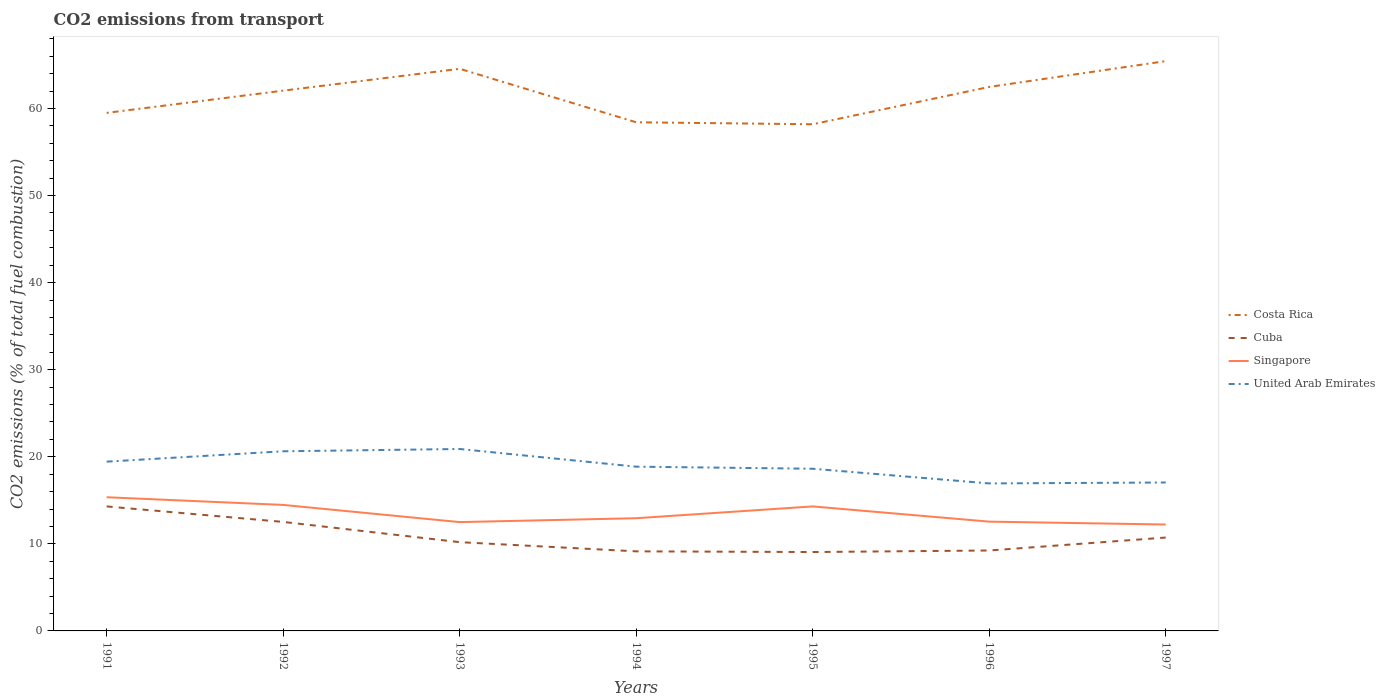Is the number of lines equal to the number of legend labels?
Make the answer very short. Yes. Across all years, what is the maximum total CO2 emitted in Costa Rica?
Give a very brief answer. 58.18. In which year was the total CO2 emitted in Costa Rica maximum?
Give a very brief answer. 1995. What is the total total CO2 emitted in Costa Rica in the graph?
Ensure brevity in your answer.  -2.55. What is the difference between the highest and the second highest total CO2 emitted in Singapore?
Offer a very short reply. 3.13. What is the difference between the highest and the lowest total CO2 emitted in Costa Rica?
Keep it short and to the point. 4. How many lines are there?
Your answer should be very brief. 4. What is the difference between two consecutive major ticks on the Y-axis?
Your answer should be compact. 10. Does the graph contain grids?
Give a very brief answer. No. How many legend labels are there?
Provide a short and direct response. 4. How are the legend labels stacked?
Your answer should be compact. Vertical. What is the title of the graph?
Offer a very short reply. CO2 emissions from transport. What is the label or title of the X-axis?
Ensure brevity in your answer.  Years. What is the label or title of the Y-axis?
Provide a short and direct response. CO2 emissions (% of total fuel combustion). What is the CO2 emissions (% of total fuel combustion) of Costa Rica in 1991?
Make the answer very short. 59.49. What is the CO2 emissions (% of total fuel combustion) in Cuba in 1991?
Keep it short and to the point. 14.3. What is the CO2 emissions (% of total fuel combustion) in Singapore in 1991?
Your answer should be compact. 15.35. What is the CO2 emissions (% of total fuel combustion) in United Arab Emirates in 1991?
Provide a short and direct response. 19.44. What is the CO2 emissions (% of total fuel combustion) in Costa Rica in 1992?
Your answer should be very brief. 62.04. What is the CO2 emissions (% of total fuel combustion) in Cuba in 1992?
Provide a short and direct response. 12.52. What is the CO2 emissions (% of total fuel combustion) in Singapore in 1992?
Keep it short and to the point. 14.47. What is the CO2 emissions (% of total fuel combustion) of United Arab Emirates in 1992?
Your answer should be very brief. 20.63. What is the CO2 emissions (% of total fuel combustion) of Costa Rica in 1993?
Offer a terse response. 64.55. What is the CO2 emissions (% of total fuel combustion) in Cuba in 1993?
Your answer should be compact. 10.19. What is the CO2 emissions (% of total fuel combustion) of Singapore in 1993?
Keep it short and to the point. 12.5. What is the CO2 emissions (% of total fuel combustion) of United Arab Emirates in 1993?
Your answer should be compact. 20.89. What is the CO2 emissions (% of total fuel combustion) of Costa Rica in 1994?
Make the answer very short. 58.41. What is the CO2 emissions (% of total fuel combustion) of Cuba in 1994?
Your response must be concise. 9.14. What is the CO2 emissions (% of total fuel combustion) in Singapore in 1994?
Offer a very short reply. 12.94. What is the CO2 emissions (% of total fuel combustion) in United Arab Emirates in 1994?
Offer a terse response. 18.86. What is the CO2 emissions (% of total fuel combustion) in Costa Rica in 1995?
Give a very brief answer. 58.18. What is the CO2 emissions (% of total fuel combustion) in Cuba in 1995?
Keep it short and to the point. 9.06. What is the CO2 emissions (% of total fuel combustion) in Singapore in 1995?
Provide a short and direct response. 14.3. What is the CO2 emissions (% of total fuel combustion) in United Arab Emirates in 1995?
Make the answer very short. 18.62. What is the CO2 emissions (% of total fuel combustion) in Costa Rica in 1996?
Provide a short and direct response. 62.47. What is the CO2 emissions (% of total fuel combustion) of Cuba in 1996?
Provide a succinct answer. 9.24. What is the CO2 emissions (% of total fuel combustion) of Singapore in 1996?
Provide a short and direct response. 12.55. What is the CO2 emissions (% of total fuel combustion) in United Arab Emirates in 1996?
Provide a succinct answer. 16.94. What is the CO2 emissions (% of total fuel combustion) of Costa Rica in 1997?
Give a very brief answer. 65.43. What is the CO2 emissions (% of total fuel combustion) in Cuba in 1997?
Give a very brief answer. 10.72. What is the CO2 emissions (% of total fuel combustion) of Singapore in 1997?
Keep it short and to the point. 12.22. What is the CO2 emissions (% of total fuel combustion) of United Arab Emirates in 1997?
Offer a terse response. 17.04. Across all years, what is the maximum CO2 emissions (% of total fuel combustion) in Costa Rica?
Provide a succinct answer. 65.43. Across all years, what is the maximum CO2 emissions (% of total fuel combustion) in Cuba?
Your answer should be very brief. 14.3. Across all years, what is the maximum CO2 emissions (% of total fuel combustion) in Singapore?
Make the answer very short. 15.35. Across all years, what is the maximum CO2 emissions (% of total fuel combustion) of United Arab Emirates?
Your answer should be very brief. 20.89. Across all years, what is the minimum CO2 emissions (% of total fuel combustion) in Costa Rica?
Your response must be concise. 58.18. Across all years, what is the minimum CO2 emissions (% of total fuel combustion) of Cuba?
Your response must be concise. 9.06. Across all years, what is the minimum CO2 emissions (% of total fuel combustion) in Singapore?
Provide a succinct answer. 12.22. Across all years, what is the minimum CO2 emissions (% of total fuel combustion) of United Arab Emirates?
Offer a very short reply. 16.94. What is the total CO2 emissions (% of total fuel combustion) of Costa Rica in the graph?
Provide a succinct answer. 430.57. What is the total CO2 emissions (% of total fuel combustion) of Cuba in the graph?
Make the answer very short. 75.16. What is the total CO2 emissions (% of total fuel combustion) of Singapore in the graph?
Provide a short and direct response. 94.33. What is the total CO2 emissions (% of total fuel combustion) in United Arab Emirates in the graph?
Give a very brief answer. 132.43. What is the difference between the CO2 emissions (% of total fuel combustion) of Costa Rica in 1991 and that in 1992?
Give a very brief answer. -2.55. What is the difference between the CO2 emissions (% of total fuel combustion) in Cuba in 1991 and that in 1992?
Give a very brief answer. 1.78. What is the difference between the CO2 emissions (% of total fuel combustion) of Singapore in 1991 and that in 1992?
Your response must be concise. 0.88. What is the difference between the CO2 emissions (% of total fuel combustion) of United Arab Emirates in 1991 and that in 1992?
Give a very brief answer. -1.19. What is the difference between the CO2 emissions (% of total fuel combustion) of Costa Rica in 1991 and that in 1993?
Your answer should be very brief. -5.06. What is the difference between the CO2 emissions (% of total fuel combustion) in Cuba in 1991 and that in 1993?
Your answer should be very brief. 4.1. What is the difference between the CO2 emissions (% of total fuel combustion) of Singapore in 1991 and that in 1993?
Make the answer very short. 2.85. What is the difference between the CO2 emissions (% of total fuel combustion) of United Arab Emirates in 1991 and that in 1993?
Your response must be concise. -1.45. What is the difference between the CO2 emissions (% of total fuel combustion) in Cuba in 1991 and that in 1994?
Give a very brief answer. 5.16. What is the difference between the CO2 emissions (% of total fuel combustion) of Singapore in 1991 and that in 1994?
Ensure brevity in your answer.  2.41. What is the difference between the CO2 emissions (% of total fuel combustion) in United Arab Emirates in 1991 and that in 1994?
Your answer should be very brief. 0.58. What is the difference between the CO2 emissions (% of total fuel combustion) in Costa Rica in 1991 and that in 1995?
Keep it short and to the point. 1.31. What is the difference between the CO2 emissions (% of total fuel combustion) in Cuba in 1991 and that in 1995?
Provide a succinct answer. 5.24. What is the difference between the CO2 emissions (% of total fuel combustion) of Singapore in 1991 and that in 1995?
Your response must be concise. 1.05. What is the difference between the CO2 emissions (% of total fuel combustion) in United Arab Emirates in 1991 and that in 1995?
Your answer should be compact. 0.81. What is the difference between the CO2 emissions (% of total fuel combustion) in Costa Rica in 1991 and that in 1996?
Provide a short and direct response. -2.98. What is the difference between the CO2 emissions (% of total fuel combustion) of Cuba in 1991 and that in 1996?
Provide a succinct answer. 5.06. What is the difference between the CO2 emissions (% of total fuel combustion) in Singapore in 1991 and that in 1996?
Keep it short and to the point. 2.8. What is the difference between the CO2 emissions (% of total fuel combustion) of United Arab Emirates in 1991 and that in 1996?
Your answer should be compact. 2.5. What is the difference between the CO2 emissions (% of total fuel combustion) in Costa Rica in 1991 and that in 1997?
Your answer should be very brief. -5.94. What is the difference between the CO2 emissions (% of total fuel combustion) in Cuba in 1991 and that in 1997?
Offer a terse response. 3.57. What is the difference between the CO2 emissions (% of total fuel combustion) in Singapore in 1991 and that in 1997?
Offer a very short reply. 3.13. What is the difference between the CO2 emissions (% of total fuel combustion) of United Arab Emirates in 1991 and that in 1997?
Offer a terse response. 2.39. What is the difference between the CO2 emissions (% of total fuel combustion) in Costa Rica in 1992 and that in 1993?
Offer a terse response. -2.51. What is the difference between the CO2 emissions (% of total fuel combustion) in Cuba in 1992 and that in 1993?
Give a very brief answer. 2.32. What is the difference between the CO2 emissions (% of total fuel combustion) in Singapore in 1992 and that in 1993?
Your answer should be compact. 1.97. What is the difference between the CO2 emissions (% of total fuel combustion) of United Arab Emirates in 1992 and that in 1993?
Provide a succinct answer. -0.26. What is the difference between the CO2 emissions (% of total fuel combustion) in Costa Rica in 1992 and that in 1994?
Provide a short and direct response. 3.63. What is the difference between the CO2 emissions (% of total fuel combustion) in Cuba in 1992 and that in 1994?
Offer a terse response. 3.38. What is the difference between the CO2 emissions (% of total fuel combustion) in Singapore in 1992 and that in 1994?
Your response must be concise. 1.53. What is the difference between the CO2 emissions (% of total fuel combustion) in United Arab Emirates in 1992 and that in 1994?
Give a very brief answer. 1.77. What is the difference between the CO2 emissions (% of total fuel combustion) of Costa Rica in 1992 and that in 1995?
Offer a terse response. 3.86. What is the difference between the CO2 emissions (% of total fuel combustion) of Cuba in 1992 and that in 1995?
Make the answer very short. 3.46. What is the difference between the CO2 emissions (% of total fuel combustion) in Singapore in 1992 and that in 1995?
Your answer should be very brief. 0.17. What is the difference between the CO2 emissions (% of total fuel combustion) in United Arab Emirates in 1992 and that in 1995?
Your response must be concise. 2. What is the difference between the CO2 emissions (% of total fuel combustion) in Costa Rica in 1992 and that in 1996?
Your answer should be very brief. -0.43. What is the difference between the CO2 emissions (% of total fuel combustion) in Cuba in 1992 and that in 1996?
Your response must be concise. 3.28. What is the difference between the CO2 emissions (% of total fuel combustion) in Singapore in 1992 and that in 1996?
Give a very brief answer. 1.92. What is the difference between the CO2 emissions (% of total fuel combustion) in United Arab Emirates in 1992 and that in 1996?
Ensure brevity in your answer.  3.69. What is the difference between the CO2 emissions (% of total fuel combustion) in Costa Rica in 1992 and that in 1997?
Your response must be concise. -3.39. What is the difference between the CO2 emissions (% of total fuel combustion) in Cuba in 1992 and that in 1997?
Ensure brevity in your answer.  1.79. What is the difference between the CO2 emissions (% of total fuel combustion) of Singapore in 1992 and that in 1997?
Your answer should be very brief. 2.25. What is the difference between the CO2 emissions (% of total fuel combustion) in United Arab Emirates in 1992 and that in 1997?
Keep it short and to the point. 3.58. What is the difference between the CO2 emissions (% of total fuel combustion) in Costa Rica in 1993 and that in 1994?
Give a very brief answer. 6.14. What is the difference between the CO2 emissions (% of total fuel combustion) in Cuba in 1993 and that in 1994?
Ensure brevity in your answer.  1.06. What is the difference between the CO2 emissions (% of total fuel combustion) in Singapore in 1993 and that in 1994?
Offer a very short reply. -0.45. What is the difference between the CO2 emissions (% of total fuel combustion) in United Arab Emirates in 1993 and that in 1994?
Your response must be concise. 2.03. What is the difference between the CO2 emissions (% of total fuel combustion) of Costa Rica in 1993 and that in 1995?
Make the answer very short. 6.37. What is the difference between the CO2 emissions (% of total fuel combustion) in Cuba in 1993 and that in 1995?
Ensure brevity in your answer.  1.14. What is the difference between the CO2 emissions (% of total fuel combustion) of Singapore in 1993 and that in 1995?
Your answer should be very brief. -1.8. What is the difference between the CO2 emissions (% of total fuel combustion) in United Arab Emirates in 1993 and that in 1995?
Offer a very short reply. 2.27. What is the difference between the CO2 emissions (% of total fuel combustion) in Costa Rica in 1993 and that in 1996?
Ensure brevity in your answer.  2.08. What is the difference between the CO2 emissions (% of total fuel combustion) in Cuba in 1993 and that in 1996?
Offer a terse response. 0.96. What is the difference between the CO2 emissions (% of total fuel combustion) of Singapore in 1993 and that in 1996?
Your response must be concise. -0.05. What is the difference between the CO2 emissions (% of total fuel combustion) in United Arab Emirates in 1993 and that in 1996?
Make the answer very short. 3.95. What is the difference between the CO2 emissions (% of total fuel combustion) of Costa Rica in 1993 and that in 1997?
Your response must be concise. -0.88. What is the difference between the CO2 emissions (% of total fuel combustion) in Cuba in 1993 and that in 1997?
Keep it short and to the point. -0.53. What is the difference between the CO2 emissions (% of total fuel combustion) in Singapore in 1993 and that in 1997?
Keep it short and to the point. 0.28. What is the difference between the CO2 emissions (% of total fuel combustion) in United Arab Emirates in 1993 and that in 1997?
Keep it short and to the point. 3.85. What is the difference between the CO2 emissions (% of total fuel combustion) of Costa Rica in 1994 and that in 1995?
Provide a short and direct response. 0.23. What is the difference between the CO2 emissions (% of total fuel combustion) in Cuba in 1994 and that in 1995?
Keep it short and to the point. 0.08. What is the difference between the CO2 emissions (% of total fuel combustion) of Singapore in 1994 and that in 1995?
Offer a very short reply. -1.35. What is the difference between the CO2 emissions (% of total fuel combustion) of United Arab Emirates in 1994 and that in 1995?
Provide a short and direct response. 0.24. What is the difference between the CO2 emissions (% of total fuel combustion) of Costa Rica in 1994 and that in 1996?
Keep it short and to the point. -4.06. What is the difference between the CO2 emissions (% of total fuel combustion) in Cuba in 1994 and that in 1996?
Offer a terse response. -0.1. What is the difference between the CO2 emissions (% of total fuel combustion) in Singapore in 1994 and that in 1996?
Make the answer very short. 0.39. What is the difference between the CO2 emissions (% of total fuel combustion) in United Arab Emirates in 1994 and that in 1996?
Make the answer very short. 1.92. What is the difference between the CO2 emissions (% of total fuel combustion) of Costa Rica in 1994 and that in 1997?
Offer a very short reply. -7.02. What is the difference between the CO2 emissions (% of total fuel combustion) in Cuba in 1994 and that in 1997?
Make the answer very short. -1.59. What is the difference between the CO2 emissions (% of total fuel combustion) in Singapore in 1994 and that in 1997?
Your response must be concise. 0.72. What is the difference between the CO2 emissions (% of total fuel combustion) of United Arab Emirates in 1994 and that in 1997?
Ensure brevity in your answer.  1.82. What is the difference between the CO2 emissions (% of total fuel combustion) in Costa Rica in 1995 and that in 1996?
Ensure brevity in your answer.  -4.29. What is the difference between the CO2 emissions (% of total fuel combustion) of Cuba in 1995 and that in 1996?
Provide a short and direct response. -0.18. What is the difference between the CO2 emissions (% of total fuel combustion) of Singapore in 1995 and that in 1996?
Provide a succinct answer. 1.75. What is the difference between the CO2 emissions (% of total fuel combustion) of United Arab Emirates in 1995 and that in 1996?
Provide a succinct answer. 1.69. What is the difference between the CO2 emissions (% of total fuel combustion) of Costa Rica in 1995 and that in 1997?
Ensure brevity in your answer.  -7.25. What is the difference between the CO2 emissions (% of total fuel combustion) of Cuba in 1995 and that in 1997?
Give a very brief answer. -1.67. What is the difference between the CO2 emissions (% of total fuel combustion) in Singapore in 1995 and that in 1997?
Provide a short and direct response. 2.08. What is the difference between the CO2 emissions (% of total fuel combustion) in United Arab Emirates in 1995 and that in 1997?
Offer a very short reply. 1.58. What is the difference between the CO2 emissions (% of total fuel combustion) in Costa Rica in 1996 and that in 1997?
Make the answer very short. -2.96. What is the difference between the CO2 emissions (% of total fuel combustion) of Cuba in 1996 and that in 1997?
Give a very brief answer. -1.49. What is the difference between the CO2 emissions (% of total fuel combustion) in Singapore in 1996 and that in 1997?
Ensure brevity in your answer.  0.33. What is the difference between the CO2 emissions (% of total fuel combustion) of United Arab Emirates in 1996 and that in 1997?
Your answer should be very brief. -0.11. What is the difference between the CO2 emissions (% of total fuel combustion) in Costa Rica in 1991 and the CO2 emissions (% of total fuel combustion) in Cuba in 1992?
Your response must be concise. 46.97. What is the difference between the CO2 emissions (% of total fuel combustion) of Costa Rica in 1991 and the CO2 emissions (% of total fuel combustion) of Singapore in 1992?
Your answer should be very brief. 45.02. What is the difference between the CO2 emissions (% of total fuel combustion) of Costa Rica in 1991 and the CO2 emissions (% of total fuel combustion) of United Arab Emirates in 1992?
Your response must be concise. 38.86. What is the difference between the CO2 emissions (% of total fuel combustion) of Cuba in 1991 and the CO2 emissions (% of total fuel combustion) of Singapore in 1992?
Your response must be concise. -0.17. What is the difference between the CO2 emissions (% of total fuel combustion) in Cuba in 1991 and the CO2 emissions (% of total fuel combustion) in United Arab Emirates in 1992?
Offer a terse response. -6.33. What is the difference between the CO2 emissions (% of total fuel combustion) of Singapore in 1991 and the CO2 emissions (% of total fuel combustion) of United Arab Emirates in 1992?
Ensure brevity in your answer.  -5.28. What is the difference between the CO2 emissions (% of total fuel combustion) in Costa Rica in 1991 and the CO2 emissions (% of total fuel combustion) in Cuba in 1993?
Your answer should be very brief. 49.3. What is the difference between the CO2 emissions (% of total fuel combustion) in Costa Rica in 1991 and the CO2 emissions (% of total fuel combustion) in Singapore in 1993?
Provide a short and direct response. 46.99. What is the difference between the CO2 emissions (% of total fuel combustion) of Costa Rica in 1991 and the CO2 emissions (% of total fuel combustion) of United Arab Emirates in 1993?
Keep it short and to the point. 38.6. What is the difference between the CO2 emissions (% of total fuel combustion) in Cuba in 1991 and the CO2 emissions (% of total fuel combustion) in Singapore in 1993?
Ensure brevity in your answer.  1.8. What is the difference between the CO2 emissions (% of total fuel combustion) of Cuba in 1991 and the CO2 emissions (% of total fuel combustion) of United Arab Emirates in 1993?
Give a very brief answer. -6.59. What is the difference between the CO2 emissions (% of total fuel combustion) in Singapore in 1991 and the CO2 emissions (% of total fuel combustion) in United Arab Emirates in 1993?
Your answer should be compact. -5.54. What is the difference between the CO2 emissions (% of total fuel combustion) in Costa Rica in 1991 and the CO2 emissions (% of total fuel combustion) in Cuba in 1994?
Give a very brief answer. 50.35. What is the difference between the CO2 emissions (% of total fuel combustion) in Costa Rica in 1991 and the CO2 emissions (% of total fuel combustion) in Singapore in 1994?
Make the answer very short. 46.55. What is the difference between the CO2 emissions (% of total fuel combustion) in Costa Rica in 1991 and the CO2 emissions (% of total fuel combustion) in United Arab Emirates in 1994?
Provide a succinct answer. 40.63. What is the difference between the CO2 emissions (% of total fuel combustion) in Cuba in 1991 and the CO2 emissions (% of total fuel combustion) in Singapore in 1994?
Provide a succinct answer. 1.35. What is the difference between the CO2 emissions (% of total fuel combustion) of Cuba in 1991 and the CO2 emissions (% of total fuel combustion) of United Arab Emirates in 1994?
Provide a short and direct response. -4.57. What is the difference between the CO2 emissions (% of total fuel combustion) in Singapore in 1991 and the CO2 emissions (% of total fuel combustion) in United Arab Emirates in 1994?
Your answer should be very brief. -3.51. What is the difference between the CO2 emissions (% of total fuel combustion) in Costa Rica in 1991 and the CO2 emissions (% of total fuel combustion) in Cuba in 1995?
Offer a very short reply. 50.43. What is the difference between the CO2 emissions (% of total fuel combustion) in Costa Rica in 1991 and the CO2 emissions (% of total fuel combustion) in Singapore in 1995?
Provide a short and direct response. 45.19. What is the difference between the CO2 emissions (% of total fuel combustion) in Costa Rica in 1991 and the CO2 emissions (% of total fuel combustion) in United Arab Emirates in 1995?
Make the answer very short. 40.86. What is the difference between the CO2 emissions (% of total fuel combustion) of Cuba in 1991 and the CO2 emissions (% of total fuel combustion) of Singapore in 1995?
Provide a short and direct response. -0. What is the difference between the CO2 emissions (% of total fuel combustion) of Cuba in 1991 and the CO2 emissions (% of total fuel combustion) of United Arab Emirates in 1995?
Your answer should be compact. -4.33. What is the difference between the CO2 emissions (% of total fuel combustion) in Singapore in 1991 and the CO2 emissions (% of total fuel combustion) in United Arab Emirates in 1995?
Provide a succinct answer. -3.27. What is the difference between the CO2 emissions (% of total fuel combustion) in Costa Rica in 1991 and the CO2 emissions (% of total fuel combustion) in Cuba in 1996?
Your answer should be very brief. 50.25. What is the difference between the CO2 emissions (% of total fuel combustion) of Costa Rica in 1991 and the CO2 emissions (% of total fuel combustion) of Singapore in 1996?
Your response must be concise. 46.94. What is the difference between the CO2 emissions (% of total fuel combustion) of Costa Rica in 1991 and the CO2 emissions (% of total fuel combustion) of United Arab Emirates in 1996?
Provide a succinct answer. 42.55. What is the difference between the CO2 emissions (% of total fuel combustion) of Cuba in 1991 and the CO2 emissions (% of total fuel combustion) of Singapore in 1996?
Your answer should be compact. 1.75. What is the difference between the CO2 emissions (% of total fuel combustion) in Cuba in 1991 and the CO2 emissions (% of total fuel combustion) in United Arab Emirates in 1996?
Offer a very short reply. -2.64. What is the difference between the CO2 emissions (% of total fuel combustion) in Singapore in 1991 and the CO2 emissions (% of total fuel combustion) in United Arab Emirates in 1996?
Keep it short and to the point. -1.59. What is the difference between the CO2 emissions (% of total fuel combustion) of Costa Rica in 1991 and the CO2 emissions (% of total fuel combustion) of Cuba in 1997?
Give a very brief answer. 48.77. What is the difference between the CO2 emissions (% of total fuel combustion) in Costa Rica in 1991 and the CO2 emissions (% of total fuel combustion) in Singapore in 1997?
Your answer should be very brief. 47.27. What is the difference between the CO2 emissions (% of total fuel combustion) of Costa Rica in 1991 and the CO2 emissions (% of total fuel combustion) of United Arab Emirates in 1997?
Your response must be concise. 42.44. What is the difference between the CO2 emissions (% of total fuel combustion) in Cuba in 1991 and the CO2 emissions (% of total fuel combustion) in Singapore in 1997?
Give a very brief answer. 2.08. What is the difference between the CO2 emissions (% of total fuel combustion) in Cuba in 1991 and the CO2 emissions (% of total fuel combustion) in United Arab Emirates in 1997?
Keep it short and to the point. -2.75. What is the difference between the CO2 emissions (% of total fuel combustion) of Singapore in 1991 and the CO2 emissions (% of total fuel combustion) of United Arab Emirates in 1997?
Provide a short and direct response. -1.69. What is the difference between the CO2 emissions (% of total fuel combustion) in Costa Rica in 1992 and the CO2 emissions (% of total fuel combustion) in Cuba in 1993?
Ensure brevity in your answer.  51.85. What is the difference between the CO2 emissions (% of total fuel combustion) of Costa Rica in 1992 and the CO2 emissions (% of total fuel combustion) of Singapore in 1993?
Your response must be concise. 49.55. What is the difference between the CO2 emissions (% of total fuel combustion) in Costa Rica in 1992 and the CO2 emissions (% of total fuel combustion) in United Arab Emirates in 1993?
Your answer should be very brief. 41.15. What is the difference between the CO2 emissions (% of total fuel combustion) of Cuba in 1992 and the CO2 emissions (% of total fuel combustion) of Singapore in 1993?
Offer a very short reply. 0.02. What is the difference between the CO2 emissions (% of total fuel combustion) of Cuba in 1992 and the CO2 emissions (% of total fuel combustion) of United Arab Emirates in 1993?
Offer a very short reply. -8.37. What is the difference between the CO2 emissions (% of total fuel combustion) of Singapore in 1992 and the CO2 emissions (% of total fuel combustion) of United Arab Emirates in 1993?
Your answer should be compact. -6.42. What is the difference between the CO2 emissions (% of total fuel combustion) in Costa Rica in 1992 and the CO2 emissions (% of total fuel combustion) in Cuba in 1994?
Your response must be concise. 52.9. What is the difference between the CO2 emissions (% of total fuel combustion) of Costa Rica in 1992 and the CO2 emissions (% of total fuel combustion) of Singapore in 1994?
Provide a short and direct response. 49.1. What is the difference between the CO2 emissions (% of total fuel combustion) in Costa Rica in 1992 and the CO2 emissions (% of total fuel combustion) in United Arab Emirates in 1994?
Your response must be concise. 43.18. What is the difference between the CO2 emissions (% of total fuel combustion) in Cuba in 1992 and the CO2 emissions (% of total fuel combustion) in Singapore in 1994?
Your answer should be very brief. -0.42. What is the difference between the CO2 emissions (% of total fuel combustion) in Cuba in 1992 and the CO2 emissions (% of total fuel combustion) in United Arab Emirates in 1994?
Provide a succinct answer. -6.34. What is the difference between the CO2 emissions (% of total fuel combustion) of Singapore in 1992 and the CO2 emissions (% of total fuel combustion) of United Arab Emirates in 1994?
Your response must be concise. -4.39. What is the difference between the CO2 emissions (% of total fuel combustion) of Costa Rica in 1992 and the CO2 emissions (% of total fuel combustion) of Cuba in 1995?
Your response must be concise. 52.98. What is the difference between the CO2 emissions (% of total fuel combustion) in Costa Rica in 1992 and the CO2 emissions (% of total fuel combustion) in Singapore in 1995?
Ensure brevity in your answer.  47.75. What is the difference between the CO2 emissions (% of total fuel combustion) in Costa Rica in 1992 and the CO2 emissions (% of total fuel combustion) in United Arab Emirates in 1995?
Your answer should be compact. 43.42. What is the difference between the CO2 emissions (% of total fuel combustion) of Cuba in 1992 and the CO2 emissions (% of total fuel combustion) of Singapore in 1995?
Keep it short and to the point. -1.78. What is the difference between the CO2 emissions (% of total fuel combustion) of Cuba in 1992 and the CO2 emissions (% of total fuel combustion) of United Arab Emirates in 1995?
Ensure brevity in your answer.  -6.11. What is the difference between the CO2 emissions (% of total fuel combustion) of Singapore in 1992 and the CO2 emissions (% of total fuel combustion) of United Arab Emirates in 1995?
Your answer should be compact. -4.15. What is the difference between the CO2 emissions (% of total fuel combustion) of Costa Rica in 1992 and the CO2 emissions (% of total fuel combustion) of Cuba in 1996?
Your response must be concise. 52.81. What is the difference between the CO2 emissions (% of total fuel combustion) in Costa Rica in 1992 and the CO2 emissions (% of total fuel combustion) in Singapore in 1996?
Make the answer very short. 49.49. What is the difference between the CO2 emissions (% of total fuel combustion) of Costa Rica in 1992 and the CO2 emissions (% of total fuel combustion) of United Arab Emirates in 1996?
Provide a short and direct response. 45.1. What is the difference between the CO2 emissions (% of total fuel combustion) in Cuba in 1992 and the CO2 emissions (% of total fuel combustion) in Singapore in 1996?
Your response must be concise. -0.03. What is the difference between the CO2 emissions (% of total fuel combustion) in Cuba in 1992 and the CO2 emissions (% of total fuel combustion) in United Arab Emirates in 1996?
Offer a terse response. -4.42. What is the difference between the CO2 emissions (% of total fuel combustion) in Singapore in 1992 and the CO2 emissions (% of total fuel combustion) in United Arab Emirates in 1996?
Ensure brevity in your answer.  -2.47. What is the difference between the CO2 emissions (% of total fuel combustion) in Costa Rica in 1992 and the CO2 emissions (% of total fuel combustion) in Cuba in 1997?
Keep it short and to the point. 51.32. What is the difference between the CO2 emissions (% of total fuel combustion) of Costa Rica in 1992 and the CO2 emissions (% of total fuel combustion) of Singapore in 1997?
Keep it short and to the point. 49.82. What is the difference between the CO2 emissions (% of total fuel combustion) of Costa Rica in 1992 and the CO2 emissions (% of total fuel combustion) of United Arab Emirates in 1997?
Offer a terse response. 45. What is the difference between the CO2 emissions (% of total fuel combustion) in Cuba in 1992 and the CO2 emissions (% of total fuel combustion) in Singapore in 1997?
Give a very brief answer. 0.3. What is the difference between the CO2 emissions (% of total fuel combustion) in Cuba in 1992 and the CO2 emissions (% of total fuel combustion) in United Arab Emirates in 1997?
Make the answer very short. -4.53. What is the difference between the CO2 emissions (% of total fuel combustion) in Singapore in 1992 and the CO2 emissions (% of total fuel combustion) in United Arab Emirates in 1997?
Your response must be concise. -2.57. What is the difference between the CO2 emissions (% of total fuel combustion) of Costa Rica in 1993 and the CO2 emissions (% of total fuel combustion) of Cuba in 1994?
Make the answer very short. 55.41. What is the difference between the CO2 emissions (% of total fuel combustion) of Costa Rica in 1993 and the CO2 emissions (% of total fuel combustion) of Singapore in 1994?
Offer a terse response. 51.61. What is the difference between the CO2 emissions (% of total fuel combustion) in Costa Rica in 1993 and the CO2 emissions (% of total fuel combustion) in United Arab Emirates in 1994?
Offer a terse response. 45.69. What is the difference between the CO2 emissions (% of total fuel combustion) in Cuba in 1993 and the CO2 emissions (% of total fuel combustion) in Singapore in 1994?
Make the answer very short. -2.75. What is the difference between the CO2 emissions (% of total fuel combustion) in Cuba in 1993 and the CO2 emissions (% of total fuel combustion) in United Arab Emirates in 1994?
Provide a short and direct response. -8.67. What is the difference between the CO2 emissions (% of total fuel combustion) of Singapore in 1993 and the CO2 emissions (% of total fuel combustion) of United Arab Emirates in 1994?
Keep it short and to the point. -6.36. What is the difference between the CO2 emissions (% of total fuel combustion) of Costa Rica in 1993 and the CO2 emissions (% of total fuel combustion) of Cuba in 1995?
Your answer should be very brief. 55.49. What is the difference between the CO2 emissions (% of total fuel combustion) in Costa Rica in 1993 and the CO2 emissions (% of total fuel combustion) in Singapore in 1995?
Ensure brevity in your answer.  50.25. What is the difference between the CO2 emissions (% of total fuel combustion) in Costa Rica in 1993 and the CO2 emissions (% of total fuel combustion) in United Arab Emirates in 1995?
Your answer should be compact. 45.93. What is the difference between the CO2 emissions (% of total fuel combustion) in Cuba in 1993 and the CO2 emissions (% of total fuel combustion) in Singapore in 1995?
Offer a very short reply. -4.1. What is the difference between the CO2 emissions (% of total fuel combustion) of Cuba in 1993 and the CO2 emissions (% of total fuel combustion) of United Arab Emirates in 1995?
Ensure brevity in your answer.  -8.43. What is the difference between the CO2 emissions (% of total fuel combustion) in Singapore in 1993 and the CO2 emissions (% of total fuel combustion) in United Arab Emirates in 1995?
Provide a succinct answer. -6.13. What is the difference between the CO2 emissions (% of total fuel combustion) of Costa Rica in 1993 and the CO2 emissions (% of total fuel combustion) of Cuba in 1996?
Offer a terse response. 55.31. What is the difference between the CO2 emissions (% of total fuel combustion) in Costa Rica in 1993 and the CO2 emissions (% of total fuel combustion) in Singapore in 1996?
Your answer should be very brief. 52. What is the difference between the CO2 emissions (% of total fuel combustion) of Costa Rica in 1993 and the CO2 emissions (% of total fuel combustion) of United Arab Emirates in 1996?
Give a very brief answer. 47.61. What is the difference between the CO2 emissions (% of total fuel combustion) of Cuba in 1993 and the CO2 emissions (% of total fuel combustion) of Singapore in 1996?
Offer a terse response. -2.36. What is the difference between the CO2 emissions (% of total fuel combustion) of Cuba in 1993 and the CO2 emissions (% of total fuel combustion) of United Arab Emirates in 1996?
Provide a succinct answer. -6.74. What is the difference between the CO2 emissions (% of total fuel combustion) in Singapore in 1993 and the CO2 emissions (% of total fuel combustion) in United Arab Emirates in 1996?
Your answer should be very brief. -4.44. What is the difference between the CO2 emissions (% of total fuel combustion) in Costa Rica in 1993 and the CO2 emissions (% of total fuel combustion) in Cuba in 1997?
Your response must be concise. 53.83. What is the difference between the CO2 emissions (% of total fuel combustion) in Costa Rica in 1993 and the CO2 emissions (% of total fuel combustion) in Singapore in 1997?
Offer a very short reply. 52.33. What is the difference between the CO2 emissions (% of total fuel combustion) of Costa Rica in 1993 and the CO2 emissions (% of total fuel combustion) of United Arab Emirates in 1997?
Your response must be concise. 47.51. What is the difference between the CO2 emissions (% of total fuel combustion) of Cuba in 1993 and the CO2 emissions (% of total fuel combustion) of Singapore in 1997?
Offer a very short reply. -2.03. What is the difference between the CO2 emissions (% of total fuel combustion) of Cuba in 1993 and the CO2 emissions (% of total fuel combustion) of United Arab Emirates in 1997?
Offer a very short reply. -6.85. What is the difference between the CO2 emissions (% of total fuel combustion) in Singapore in 1993 and the CO2 emissions (% of total fuel combustion) in United Arab Emirates in 1997?
Your response must be concise. -4.55. What is the difference between the CO2 emissions (% of total fuel combustion) in Costa Rica in 1994 and the CO2 emissions (% of total fuel combustion) in Cuba in 1995?
Offer a terse response. 49.35. What is the difference between the CO2 emissions (% of total fuel combustion) in Costa Rica in 1994 and the CO2 emissions (% of total fuel combustion) in Singapore in 1995?
Provide a succinct answer. 44.11. What is the difference between the CO2 emissions (% of total fuel combustion) of Costa Rica in 1994 and the CO2 emissions (% of total fuel combustion) of United Arab Emirates in 1995?
Your response must be concise. 39.78. What is the difference between the CO2 emissions (% of total fuel combustion) of Cuba in 1994 and the CO2 emissions (% of total fuel combustion) of Singapore in 1995?
Ensure brevity in your answer.  -5.16. What is the difference between the CO2 emissions (% of total fuel combustion) of Cuba in 1994 and the CO2 emissions (% of total fuel combustion) of United Arab Emirates in 1995?
Ensure brevity in your answer.  -9.49. What is the difference between the CO2 emissions (% of total fuel combustion) of Singapore in 1994 and the CO2 emissions (% of total fuel combustion) of United Arab Emirates in 1995?
Your answer should be compact. -5.68. What is the difference between the CO2 emissions (% of total fuel combustion) in Costa Rica in 1994 and the CO2 emissions (% of total fuel combustion) in Cuba in 1996?
Ensure brevity in your answer.  49.17. What is the difference between the CO2 emissions (% of total fuel combustion) of Costa Rica in 1994 and the CO2 emissions (% of total fuel combustion) of Singapore in 1996?
Your answer should be very brief. 45.86. What is the difference between the CO2 emissions (% of total fuel combustion) in Costa Rica in 1994 and the CO2 emissions (% of total fuel combustion) in United Arab Emirates in 1996?
Your answer should be compact. 41.47. What is the difference between the CO2 emissions (% of total fuel combustion) in Cuba in 1994 and the CO2 emissions (% of total fuel combustion) in Singapore in 1996?
Make the answer very short. -3.41. What is the difference between the CO2 emissions (% of total fuel combustion) in Cuba in 1994 and the CO2 emissions (% of total fuel combustion) in United Arab Emirates in 1996?
Your response must be concise. -7.8. What is the difference between the CO2 emissions (% of total fuel combustion) of Singapore in 1994 and the CO2 emissions (% of total fuel combustion) of United Arab Emirates in 1996?
Give a very brief answer. -3.99. What is the difference between the CO2 emissions (% of total fuel combustion) in Costa Rica in 1994 and the CO2 emissions (% of total fuel combustion) in Cuba in 1997?
Give a very brief answer. 47.69. What is the difference between the CO2 emissions (% of total fuel combustion) of Costa Rica in 1994 and the CO2 emissions (% of total fuel combustion) of Singapore in 1997?
Your answer should be compact. 46.19. What is the difference between the CO2 emissions (% of total fuel combustion) of Costa Rica in 1994 and the CO2 emissions (% of total fuel combustion) of United Arab Emirates in 1997?
Offer a terse response. 41.36. What is the difference between the CO2 emissions (% of total fuel combustion) in Cuba in 1994 and the CO2 emissions (% of total fuel combustion) in Singapore in 1997?
Your response must be concise. -3.08. What is the difference between the CO2 emissions (% of total fuel combustion) of Cuba in 1994 and the CO2 emissions (% of total fuel combustion) of United Arab Emirates in 1997?
Provide a succinct answer. -7.91. What is the difference between the CO2 emissions (% of total fuel combustion) of Singapore in 1994 and the CO2 emissions (% of total fuel combustion) of United Arab Emirates in 1997?
Your response must be concise. -4.1. What is the difference between the CO2 emissions (% of total fuel combustion) of Costa Rica in 1995 and the CO2 emissions (% of total fuel combustion) of Cuba in 1996?
Your answer should be compact. 48.95. What is the difference between the CO2 emissions (% of total fuel combustion) in Costa Rica in 1995 and the CO2 emissions (% of total fuel combustion) in Singapore in 1996?
Give a very brief answer. 45.63. What is the difference between the CO2 emissions (% of total fuel combustion) of Costa Rica in 1995 and the CO2 emissions (% of total fuel combustion) of United Arab Emirates in 1996?
Ensure brevity in your answer.  41.24. What is the difference between the CO2 emissions (% of total fuel combustion) in Cuba in 1995 and the CO2 emissions (% of total fuel combustion) in Singapore in 1996?
Ensure brevity in your answer.  -3.49. What is the difference between the CO2 emissions (% of total fuel combustion) in Cuba in 1995 and the CO2 emissions (% of total fuel combustion) in United Arab Emirates in 1996?
Provide a succinct answer. -7.88. What is the difference between the CO2 emissions (% of total fuel combustion) in Singapore in 1995 and the CO2 emissions (% of total fuel combustion) in United Arab Emirates in 1996?
Provide a succinct answer. -2.64. What is the difference between the CO2 emissions (% of total fuel combustion) of Costa Rica in 1995 and the CO2 emissions (% of total fuel combustion) of Cuba in 1997?
Your answer should be compact. 47.46. What is the difference between the CO2 emissions (% of total fuel combustion) of Costa Rica in 1995 and the CO2 emissions (% of total fuel combustion) of Singapore in 1997?
Provide a short and direct response. 45.96. What is the difference between the CO2 emissions (% of total fuel combustion) of Costa Rica in 1995 and the CO2 emissions (% of total fuel combustion) of United Arab Emirates in 1997?
Offer a very short reply. 41.14. What is the difference between the CO2 emissions (% of total fuel combustion) of Cuba in 1995 and the CO2 emissions (% of total fuel combustion) of Singapore in 1997?
Offer a terse response. -3.16. What is the difference between the CO2 emissions (% of total fuel combustion) in Cuba in 1995 and the CO2 emissions (% of total fuel combustion) in United Arab Emirates in 1997?
Keep it short and to the point. -7.99. What is the difference between the CO2 emissions (% of total fuel combustion) in Singapore in 1995 and the CO2 emissions (% of total fuel combustion) in United Arab Emirates in 1997?
Provide a short and direct response. -2.75. What is the difference between the CO2 emissions (% of total fuel combustion) of Costa Rica in 1996 and the CO2 emissions (% of total fuel combustion) of Cuba in 1997?
Ensure brevity in your answer.  51.75. What is the difference between the CO2 emissions (% of total fuel combustion) of Costa Rica in 1996 and the CO2 emissions (% of total fuel combustion) of Singapore in 1997?
Make the answer very short. 50.25. What is the difference between the CO2 emissions (% of total fuel combustion) of Costa Rica in 1996 and the CO2 emissions (% of total fuel combustion) of United Arab Emirates in 1997?
Ensure brevity in your answer.  45.42. What is the difference between the CO2 emissions (% of total fuel combustion) of Cuba in 1996 and the CO2 emissions (% of total fuel combustion) of Singapore in 1997?
Provide a short and direct response. -2.98. What is the difference between the CO2 emissions (% of total fuel combustion) in Cuba in 1996 and the CO2 emissions (% of total fuel combustion) in United Arab Emirates in 1997?
Keep it short and to the point. -7.81. What is the difference between the CO2 emissions (% of total fuel combustion) in Singapore in 1996 and the CO2 emissions (% of total fuel combustion) in United Arab Emirates in 1997?
Offer a terse response. -4.5. What is the average CO2 emissions (% of total fuel combustion) of Costa Rica per year?
Keep it short and to the point. 61.51. What is the average CO2 emissions (% of total fuel combustion) of Cuba per year?
Make the answer very short. 10.74. What is the average CO2 emissions (% of total fuel combustion) in Singapore per year?
Make the answer very short. 13.48. What is the average CO2 emissions (% of total fuel combustion) in United Arab Emirates per year?
Keep it short and to the point. 18.92. In the year 1991, what is the difference between the CO2 emissions (% of total fuel combustion) in Costa Rica and CO2 emissions (% of total fuel combustion) in Cuba?
Make the answer very short. 45.19. In the year 1991, what is the difference between the CO2 emissions (% of total fuel combustion) in Costa Rica and CO2 emissions (% of total fuel combustion) in Singapore?
Your answer should be very brief. 44.14. In the year 1991, what is the difference between the CO2 emissions (% of total fuel combustion) of Costa Rica and CO2 emissions (% of total fuel combustion) of United Arab Emirates?
Give a very brief answer. 40.05. In the year 1991, what is the difference between the CO2 emissions (% of total fuel combustion) of Cuba and CO2 emissions (% of total fuel combustion) of Singapore?
Make the answer very short. -1.05. In the year 1991, what is the difference between the CO2 emissions (% of total fuel combustion) of Cuba and CO2 emissions (% of total fuel combustion) of United Arab Emirates?
Provide a short and direct response. -5.14. In the year 1991, what is the difference between the CO2 emissions (% of total fuel combustion) of Singapore and CO2 emissions (% of total fuel combustion) of United Arab Emirates?
Keep it short and to the point. -4.09. In the year 1992, what is the difference between the CO2 emissions (% of total fuel combustion) of Costa Rica and CO2 emissions (% of total fuel combustion) of Cuba?
Keep it short and to the point. 49.52. In the year 1992, what is the difference between the CO2 emissions (% of total fuel combustion) in Costa Rica and CO2 emissions (% of total fuel combustion) in Singapore?
Keep it short and to the point. 47.57. In the year 1992, what is the difference between the CO2 emissions (% of total fuel combustion) of Costa Rica and CO2 emissions (% of total fuel combustion) of United Arab Emirates?
Your answer should be very brief. 41.41. In the year 1992, what is the difference between the CO2 emissions (% of total fuel combustion) of Cuba and CO2 emissions (% of total fuel combustion) of Singapore?
Provide a short and direct response. -1.95. In the year 1992, what is the difference between the CO2 emissions (% of total fuel combustion) of Cuba and CO2 emissions (% of total fuel combustion) of United Arab Emirates?
Make the answer very short. -8.11. In the year 1992, what is the difference between the CO2 emissions (% of total fuel combustion) of Singapore and CO2 emissions (% of total fuel combustion) of United Arab Emirates?
Your answer should be very brief. -6.16. In the year 1993, what is the difference between the CO2 emissions (% of total fuel combustion) in Costa Rica and CO2 emissions (% of total fuel combustion) in Cuba?
Offer a very short reply. 54.36. In the year 1993, what is the difference between the CO2 emissions (% of total fuel combustion) of Costa Rica and CO2 emissions (% of total fuel combustion) of Singapore?
Your answer should be very brief. 52.05. In the year 1993, what is the difference between the CO2 emissions (% of total fuel combustion) in Costa Rica and CO2 emissions (% of total fuel combustion) in United Arab Emirates?
Your answer should be compact. 43.66. In the year 1993, what is the difference between the CO2 emissions (% of total fuel combustion) in Cuba and CO2 emissions (% of total fuel combustion) in Singapore?
Make the answer very short. -2.3. In the year 1993, what is the difference between the CO2 emissions (% of total fuel combustion) of Cuba and CO2 emissions (% of total fuel combustion) of United Arab Emirates?
Your response must be concise. -10.7. In the year 1993, what is the difference between the CO2 emissions (% of total fuel combustion) of Singapore and CO2 emissions (% of total fuel combustion) of United Arab Emirates?
Offer a very short reply. -8.39. In the year 1994, what is the difference between the CO2 emissions (% of total fuel combustion) in Costa Rica and CO2 emissions (% of total fuel combustion) in Cuba?
Your response must be concise. 49.27. In the year 1994, what is the difference between the CO2 emissions (% of total fuel combustion) in Costa Rica and CO2 emissions (% of total fuel combustion) in Singapore?
Make the answer very short. 45.47. In the year 1994, what is the difference between the CO2 emissions (% of total fuel combustion) of Costa Rica and CO2 emissions (% of total fuel combustion) of United Arab Emirates?
Give a very brief answer. 39.55. In the year 1994, what is the difference between the CO2 emissions (% of total fuel combustion) in Cuba and CO2 emissions (% of total fuel combustion) in Singapore?
Ensure brevity in your answer.  -3.8. In the year 1994, what is the difference between the CO2 emissions (% of total fuel combustion) of Cuba and CO2 emissions (% of total fuel combustion) of United Arab Emirates?
Provide a short and direct response. -9.72. In the year 1994, what is the difference between the CO2 emissions (% of total fuel combustion) in Singapore and CO2 emissions (% of total fuel combustion) in United Arab Emirates?
Offer a terse response. -5.92. In the year 1995, what is the difference between the CO2 emissions (% of total fuel combustion) of Costa Rica and CO2 emissions (% of total fuel combustion) of Cuba?
Offer a very short reply. 49.12. In the year 1995, what is the difference between the CO2 emissions (% of total fuel combustion) of Costa Rica and CO2 emissions (% of total fuel combustion) of Singapore?
Offer a terse response. 43.89. In the year 1995, what is the difference between the CO2 emissions (% of total fuel combustion) in Costa Rica and CO2 emissions (% of total fuel combustion) in United Arab Emirates?
Provide a short and direct response. 39.56. In the year 1995, what is the difference between the CO2 emissions (% of total fuel combustion) of Cuba and CO2 emissions (% of total fuel combustion) of Singapore?
Keep it short and to the point. -5.24. In the year 1995, what is the difference between the CO2 emissions (% of total fuel combustion) in Cuba and CO2 emissions (% of total fuel combustion) in United Arab Emirates?
Provide a short and direct response. -9.57. In the year 1995, what is the difference between the CO2 emissions (% of total fuel combustion) of Singapore and CO2 emissions (% of total fuel combustion) of United Arab Emirates?
Offer a terse response. -4.33. In the year 1996, what is the difference between the CO2 emissions (% of total fuel combustion) in Costa Rica and CO2 emissions (% of total fuel combustion) in Cuba?
Your answer should be very brief. 53.23. In the year 1996, what is the difference between the CO2 emissions (% of total fuel combustion) of Costa Rica and CO2 emissions (% of total fuel combustion) of Singapore?
Your answer should be very brief. 49.92. In the year 1996, what is the difference between the CO2 emissions (% of total fuel combustion) of Costa Rica and CO2 emissions (% of total fuel combustion) of United Arab Emirates?
Provide a succinct answer. 45.53. In the year 1996, what is the difference between the CO2 emissions (% of total fuel combustion) of Cuba and CO2 emissions (% of total fuel combustion) of Singapore?
Keep it short and to the point. -3.31. In the year 1996, what is the difference between the CO2 emissions (% of total fuel combustion) in Cuba and CO2 emissions (% of total fuel combustion) in United Arab Emirates?
Your answer should be compact. -7.7. In the year 1996, what is the difference between the CO2 emissions (% of total fuel combustion) of Singapore and CO2 emissions (% of total fuel combustion) of United Arab Emirates?
Your answer should be compact. -4.39. In the year 1997, what is the difference between the CO2 emissions (% of total fuel combustion) in Costa Rica and CO2 emissions (% of total fuel combustion) in Cuba?
Offer a very short reply. 54.71. In the year 1997, what is the difference between the CO2 emissions (% of total fuel combustion) of Costa Rica and CO2 emissions (% of total fuel combustion) of Singapore?
Ensure brevity in your answer.  53.21. In the year 1997, what is the difference between the CO2 emissions (% of total fuel combustion) of Costa Rica and CO2 emissions (% of total fuel combustion) of United Arab Emirates?
Your answer should be very brief. 48.39. In the year 1997, what is the difference between the CO2 emissions (% of total fuel combustion) of Cuba and CO2 emissions (% of total fuel combustion) of Singapore?
Make the answer very short. -1.5. In the year 1997, what is the difference between the CO2 emissions (% of total fuel combustion) in Cuba and CO2 emissions (% of total fuel combustion) in United Arab Emirates?
Ensure brevity in your answer.  -6.32. In the year 1997, what is the difference between the CO2 emissions (% of total fuel combustion) in Singapore and CO2 emissions (% of total fuel combustion) in United Arab Emirates?
Offer a very short reply. -4.83. What is the ratio of the CO2 emissions (% of total fuel combustion) in Costa Rica in 1991 to that in 1992?
Make the answer very short. 0.96. What is the ratio of the CO2 emissions (% of total fuel combustion) in Cuba in 1991 to that in 1992?
Offer a terse response. 1.14. What is the ratio of the CO2 emissions (% of total fuel combustion) in Singapore in 1991 to that in 1992?
Provide a short and direct response. 1.06. What is the ratio of the CO2 emissions (% of total fuel combustion) of United Arab Emirates in 1991 to that in 1992?
Your answer should be very brief. 0.94. What is the ratio of the CO2 emissions (% of total fuel combustion) in Costa Rica in 1991 to that in 1993?
Offer a very short reply. 0.92. What is the ratio of the CO2 emissions (% of total fuel combustion) in Cuba in 1991 to that in 1993?
Your response must be concise. 1.4. What is the ratio of the CO2 emissions (% of total fuel combustion) in Singapore in 1991 to that in 1993?
Make the answer very short. 1.23. What is the ratio of the CO2 emissions (% of total fuel combustion) in United Arab Emirates in 1991 to that in 1993?
Keep it short and to the point. 0.93. What is the ratio of the CO2 emissions (% of total fuel combustion) in Costa Rica in 1991 to that in 1994?
Make the answer very short. 1.02. What is the ratio of the CO2 emissions (% of total fuel combustion) of Cuba in 1991 to that in 1994?
Your response must be concise. 1.56. What is the ratio of the CO2 emissions (% of total fuel combustion) of Singapore in 1991 to that in 1994?
Provide a succinct answer. 1.19. What is the ratio of the CO2 emissions (% of total fuel combustion) in United Arab Emirates in 1991 to that in 1994?
Make the answer very short. 1.03. What is the ratio of the CO2 emissions (% of total fuel combustion) of Costa Rica in 1991 to that in 1995?
Give a very brief answer. 1.02. What is the ratio of the CO2 emissions (% of total fuel combustion) of Cuba in 1991 to that in 1995?
Provide a succinct answer. 1.58. What is the ratio of the CO2 emissions (% of total fuel combustion) in Singapore in 1991 to that in 1995?
Provide a succinct answer. 1.07. What is the ratio of the CO2 emissions (% of total fuel combustion) in United Arab Emirates in 1991 to that in 1995?
Give a very brief answer. 1.04. What is the ratio of the CO2 emissions (% of total fuel combustion) in Costa Rica in 1991 to that in 1996?
Provide a succinct answer. 0.95. What is the ratio of the CO2 emissions (% of total fuel combustion) of Cuba in 1991 to that in 1996?
Provide a short and direct response. 1.55. What is the ratio of the CO2 emissions (% of total fuel combustion) of Singapore in 1991 to that in 1996?
Provide a succinct answer. 1.22. What is the ratio of the CO2 emissions (% of total fuel combustion) of United Arab Emirates in 1991 to that in 1996?
Provide a succinct answer. 1.15. What is the ratio of the CO2 emissions (% of total fuel combustion) in Costa Rica in 1991 to that in 1997?
Provide a short and direct response. 0.91. What is the ratio of the CO2 emissions (% of total fuel combustion) in Cuba in 1991 to that in 1997?
Your response must be concise. 1.33. What is the ratio of the CO2 emissions (% of total fuel combustion) in Singapore in 1991 to that in 1997?
Offer a very short reply. 1.26. What is the ratio of the CO2 emissions (% of total fuel combustion) in United Arab Emirates in 1991 to that in 1997?
Offer a very short reply. 1.14. What is the ratio of the CO2 emissions (% of total fuel combustion) in Costa Rica in 1992 to that in 1993?
Offer a very short reply. 0.96. What is the ratio of the CO2 emissions (% of total fuel combustion) of Cuba in 1992 to that in 1993?
Keep it short and to the point. 1.23. What is the ratio of the CO2 emissions (% of total fuel combustion) of Singapore in 1992 to that in 1993?
Your answer should be compact. 1.16. What is the ratio of the CO2 emissions (% of total fuel combustion) of United Arab Emirates in 1992 to that in 1993?
Offer a terse response. 0.99. What is the ratio of the CO2 emissions (% of total fuel combustion) of Costa Rica in 1992 to that in 1994?
Keep it short and to the point. 1.06. What is the ratio of the CO2 emissions (% of total fuel combustion) of Cuba in 1992 to that in 1994?
Your answer should be compact. 1.37. What is the ratio of the CO2 emissions (% of total fuel combustion) of Singapore in 1992 to that in 1994?
Provide a short and direct response. 1.12. What is the ratio of the CO2 emissions (% of total fuel combustion) in United Arab Emirates in 1992 to that in 1994?
Your response must be concise. 1.09. What is the ratio of the CO2 emissions (% of total fuel combustion) in Costa Rica in 1992 to that in 1995?
Your response must be concise. 1.07. What is the ratio of the CO2 emissions (% of total fuel combustion) of Cuba in 1992 to that in 1995?
Make the answer very short. 1.38. What is the ratio of the CO2 emissions (% of total fuel combustion) of Singapore in 1992 to that in 1995?
Ensure brevity in your answer.  1.01. What is the ratio of the CO2 emissions (% of total fuel combustion) of United Arab Emirates in 1992 to that in 1995?
Provide a short and direct response. 1.11. What is the ratio of the CO2 emissions (% of total fuel combustion) in Cuba in 1992 to that in 1996?
Keep it short and to the point. 1.36. What is the ratio of the CO2 emissions (% of total fuel combustion) in Singapore in 1992 to that in 1996?
Your response must be concise. 1.15. What is the ratio of the CO2 emissions (% of total fuel combustion) of United Arab Emirates in 1992 to that in 1996?
Ensure brevity in your answer.  1.22. What is the ratio of the CO2 emissions (% of total fuel combustion) in Costa Rica in 1992 to that in 1997?
Give a very brief answer. 0.95. What is the ratio of the CO2 emissions (% of total fuel combustion) of Cuba in 1992 to that in 1997?
Make the answer very short. 1.17. What is the ratio of the CO2 emissions (% of total fuel combustion) in Singapore in 1992 to that in 1997?
Your answer should be very brief. 1.18. What is the ratio of the CO2 emissions (% of total fuel combustion) in United Arab Emirates in 1992 to that in 1997?
Offer a terse response. 1.21. What is the ratio of the CO2 emissions (% of total fuel combustion) of Costa Rica in 1993 to that in 1994?
Your answer should be compact. 1.11. What is the ratio of the CO2 emissions (% of total fuel combustion) of Cuba in 1993 to that in 1994?
Your answer should be very brief. 1.12. What is the ratio of the CO2 emissions (% of total fuel combustion) in Singapore in 1993 to that in 1994?
Keep it short and to the point. 0.97. What is the ratio of the CO2 emissions (% of total fuel combustion) in United Arab Emirates in 1993 to that in 1994?
Make the answer very short. 1.11. What is the ratio of the CO2 emissions (% of total fuel combustion) in Costa Rica in 1993 to that in 1995?
Provide a short and direct response. 1.11. What is the ratio of the CO2 emissions (% of total fuel combustion) in Cuba in 1993 to that in 1995?
Make the answer very short. 1.13. What is the ratio of the CO2 emissions (% of total fuel combustion) in Singapore in 1993 to that in 1995?
Your response must be concise. 0.87. What is the ratio of the CO2 emissions (% of total fuel combustion) in United Arab Emirates in 1993 to that in 1995?
Give a very brief answer. 1.12. What is the ratio of the CO2 emissions (% of total fuel combustion) of Cuba in 1993 to that in 1996?
Offer a terse response. 1.1. What is the ratio of the CO2 emissions (% of total fuel combustion) of Singapore in 1993 to that in 1996?
Make the answer very short. 1. What is the ratio of the CO2 emissions (% of total fuel combustion) of United Arab Emirates in 1993 to that in 1996?
Your answer should be compact. 1.23. What is the ratio of the CO2 emissions (% of total fuel combustion) in Costa Rica in 1993 to that in 1997?
Offer a terse response. 0.99. What is the ratio of the CO2 emissions (% of total fuel combustion) in Cuba in 1993 to that in 1997?
Your answer should be very brief. 0.95. What is the ratio of the CO2 emissions (% of total fuel combustion) of Singapore in 1993 to that in 1997?
Offer a very short reply. 1.02. What is the ratio of the CO2 emissions (% of total fuel combustion) of United Arab Emirates in 1993 to that in 1997?
Provide a succinct answer. 1.23. What is the ratio of the CO2 emissions (% of total fuel combustion) in Cuba in 1994 to that in 1995?
Your response must be concise. 1.01. What is the ratio of the CO2 emissions (% of total fuel combustion) of Singapore in 1994 to that in 1995?
Keep it short and to the point. 0.91. What is the ratio of the CO2 emissions (% of total fuel combustion) of United Arab Emirates in 1994 to that in 1995?
Provide a short and direct response. 1.01. What is the ratio of the CO2 emissions (% of total fuel combustion) in Costa Rica in 1994 to that in 1996?
Your response must be concise. 0.94. What is the ratio of the CO2 emissions (% of total fuel combustion) in Singapore in 1994 to that in 1996?
Your response must be concise. 1.03. What is the ratio of the CO2 emissions (% of total fuel combustion) in United Arab Emirates in 1994 to that in 1996?
Offer a terse response. 1.11. What is the ratio of the CO2 emissions (% of total fuel combustion) in Costa Rica in 1994 to that in 1997?
Make the answer very short. 0.89. What is the ratio of the CO2 emissions (% of total fuel combustion) of Cuba in 1994 to that in 1997?
Keep it short and to the point. 0.85. What is the ratio of the CO2 emissions (% of total fuel combustion) of Singapore in 1994 to that in 1997?
Offer a terse response. 1.06. What is the ratio of the CO2 emissions (% of total fuel combustion) of United Arab Emirates in 1994 to that in 1997?
Your answer should be very brief. 1.11. What is the ratio of the CO2 emissions (% of total fuel combustion) in Costa Rica in 1995 to that in 1996?
Provide a succinct answer. 0.93. What is the ratio of the CO2 emissions (% of total fuel combustion) in Cuba in 1995 to that in 1996?
Give a very brief answer. 0.98. What is the ratio of the CO2 emissions (% of total fuel combustion) in Singapore in 1995 to that in 1996?
Ensure brevity in your answer.  1.14. What is the ratio of the CO2 emissions (% of total fuel combustion) of United Arab Emirates in 1995 to that in 1996?
Make the answer very short. 1.1. What is the ratio of the CO2 emissions (% of total fuel combustion) in Costa Rica in 1995 to that in 1997?
Keep it short and to the point. 0.89. What is the ratio of the CO2 emissions (% of total fuel combustion) in Cuba in 1995 to that in 1997?
Provide a succinct answer. 0.84. What is the ratio of the CO2 emissions (% of total fuel combustion) in Singapore in 1995 to that in 1997?
Offer a terse response. 1.17. What is the ratio of the CO2 emissions (% of total fuel combustion) in United Arab Emirates in 1995 to that in 1997?
Your response must be concise. 1.09. What is the ratio of the CO2 emissions (% of total fuel combustion) in Costa Rica in 1996 to that in 1997?
Offer a terse response. 0.95. What is the ratio of the CO2 emissions (% of total fuel combustion) in Cuba in 1996 to that in 1997?
Offer a terse response. 0.86. What is the ratio of the CO2 emissions (% of total fuel combustion) of United Arab Emirates in 1996 to that in 1997?
Ensure brevity in your answer.  0.99. What is the difference between the highest and the second highest CO2 emissions (% of total fuel combustion) in Costa Rica?
Provide a short and direct response. 0.88. What is the difference between the highest and the second highest CO2 emissions (% of total fuel combustion) of Cuba?
Your answer should be very brief. 1.78. What is the difference between the highest and the second highest CO2 emissions (% of total fuel combustion) of Singapore?
Offer a terse response. 0.88. What is the difference between the highest and the second highest CO2 emissions (% of total fuel combustion) in United Arab Emirates?
Make the answer very short. 0.26. What is the difference between the highest and the lowest CO2 emissions (% of total fuel combustion) in Costa Rica?
Your answer should be compact. 7.25. What is the difference between the highest and the lowest CO2 emissions (% of total fuel combustion) in Cuba?
Offer a very short reply. 5.24. What is the difference between the highest and the lowest CO2 emissions (% of total fuel combustion) in Singapore?
Your answer should be very brief. 3.13. What is the difference between the highest and the lowest CO2 emissions (% of total fuel combustion) in United Arab Emirates?
Keep it short and to the point. 3.95. 